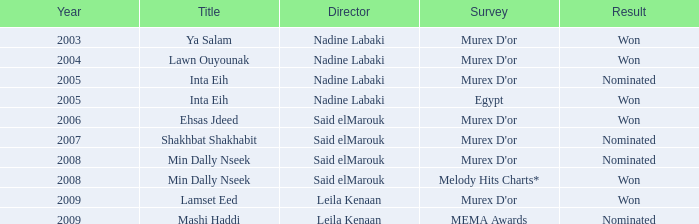Who is the helmer with the min dally nseek title, and triumphed? Said elMarouk. 